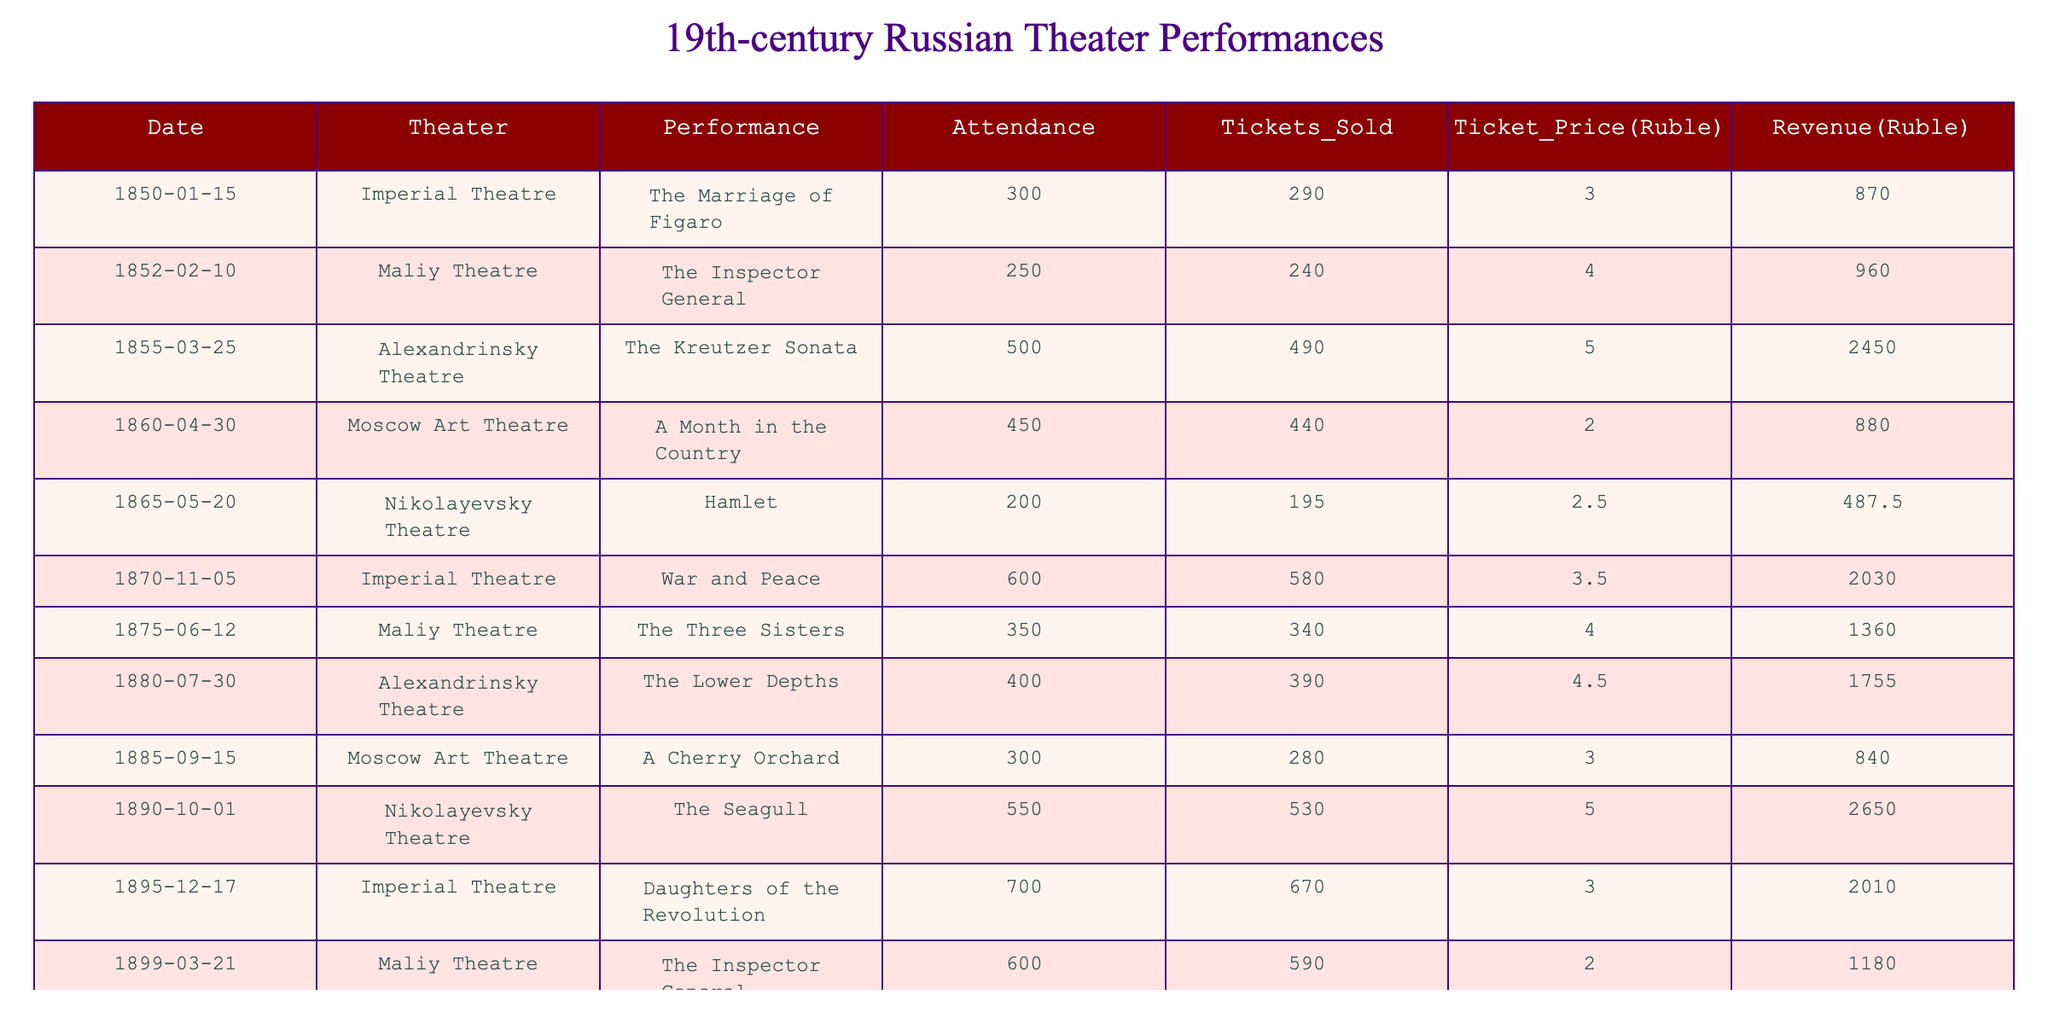What was the highest revenue generated from a single performance? By reviewing the revenue figures in the table, the highest revenue is from "Daughters of the Revolution" on December 17, 1895, which generated 2010 Rubles.
Answer: 2010 Rubles Which performance had the lowest attendance? Looking through attendance numbers, "Hamlet" on May 20, 1865, had the lowest attendance of 200.
Answer: 200 What was the total attendance across all performances? We sum all attendance numbers: 300 + 250 + 500 + 450 + 200 + 600 + 350 + 400 + 300 + 550 + 700 + 600 = 5150.
Answer: 5150 Did the "War and Peace" performance sell more tickets than the "A Month in the Country"? "War and Peace" sold 580 tickets while "A Month in the Country" sold 440 tickets. Since 580 > 440, the answer is yes.
Answer: Yes What is the average ticket price across all performances? Summing the ticket prices: 3 + 4 + 5 + 2 + 2.5 + 3.5 + 4 + 4.5 + 3 + 5 + 3 + 2 = 43, then dividing by the number of performances (12), gives an average of 43/12 ≈ 3.58.
Answer: 3.58 Rubles Which theater had the most performances recorded in the table? Counting the entries for each theater, we find that the Imperial Theatre has 3 performances while the others have fewer. Thus, it had the most.
Answer: Imperial Theatre What was the total revenue generated by performances at Maliy Theatre? The performances at Maliy Theatre generated revenues of: 960 (The Inspector General) + 1360 (The Three Sisters) + 1180 (The Inspector General) = 3500 Rubles.
Answer: 3500 Rubles Which performance had the largest attendance, and what was that number? The performance with the largest attendance was "Daughters of the Revolution" with 700 attendees on December 17, 1895.
Answer: 700 What is the difference in ticket sales between "The Seagull" and "The Lower Depths"? "The Seagull" sold 530 tickets and "The Lower Depths" sold 390 tickets. The difference is 530 - 390 = 140 tickets.
Answer: 140 tickets Which performance was held at Alexandrinsky Theatre? The performances at Alexandrinsky Theatre were "The Kreutzer Sonata" and "The Lower Depths."
Answer: The Kreutzer Sonata, The Lower Depths If we consider only performances from the 1890s, what was the average attendance? The performances from the 1890s are "The Seagull" (550) and "Daughters of the Revolution" (700). The average is (550 + 700) / 2 = 625.
Answer: 625 